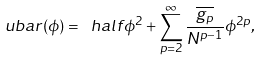Convert formula to latex. <formula><loc_0><loc_0><loc_500><loc_500>\ u b a r ( \phi ) = \ h a l f \phi ^ { 2 } + \sum _ { p = 2 } ^ { \infty } \frac { \overline { g _ { p } } } { N ^ { p - 1 } } \phi ^ { 2 p } ,</formula> 